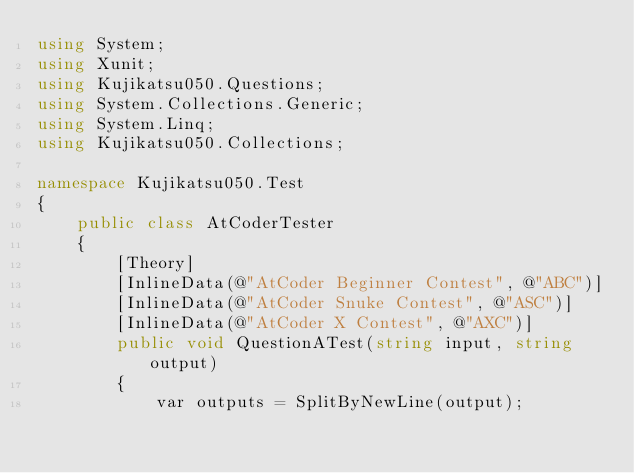Convert code to text. <code><loc_0><loc_0><loc_500><loc_500><_C#_>using System;
using Xunit;
using Kujikatsu050.Questions;
using System.Collections.Generic;
using System.Linq;
using Kujikatsu050.Collections;

namespace Kujikatsu050.Test
{
    public class AtCoderTester
    {
        [Theory]
        [InlineData(@"AtCoder Beginner Contest", @"ABC")]
        [InlineData(@"AtCoder Snuke Contest", @"ASC")]
        [InlineData(@"AtCoder X Contest", @"AXC")]
        public void QuestionATest(string input, string output)
        {
            var outputs = SplitByNewLine(output);</code> 